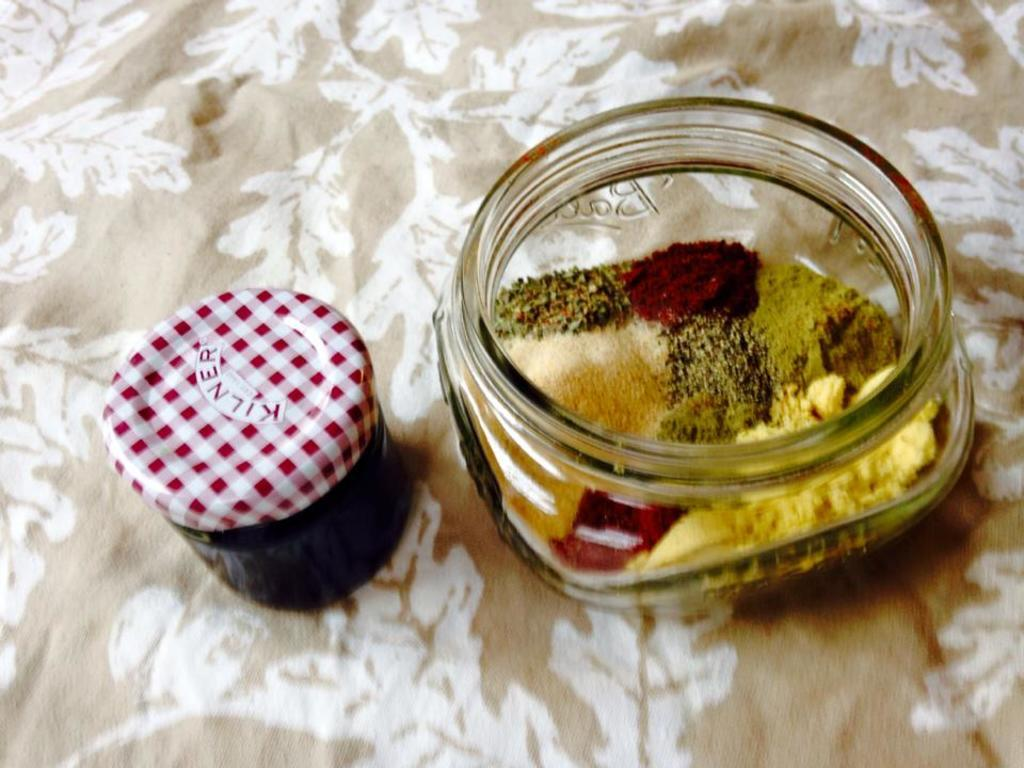How many jars can be seen in the image? There are two jars in the image. What is inside the jars? The jars contain food items. Where are the jars located? The jars are placed on a table. What type of protest is happening in the image? There is no protest present in the image; it only features two jars containing food items placed on a table. 